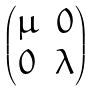<formula> <loc_0><loc_0><loc_500><loc_500>\begin{pmatrix} \mu & 0 \\ 0 & \lambda \end{pmatrix}</formula> 